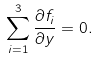Convert formula to latex. <formula><loc_0><loc_0><loc_500><loc_500>\sum _ { i = 1 } ^ { 3 } \frac { \partial f _ { i } } { \partial y } = 0 .</formula> 